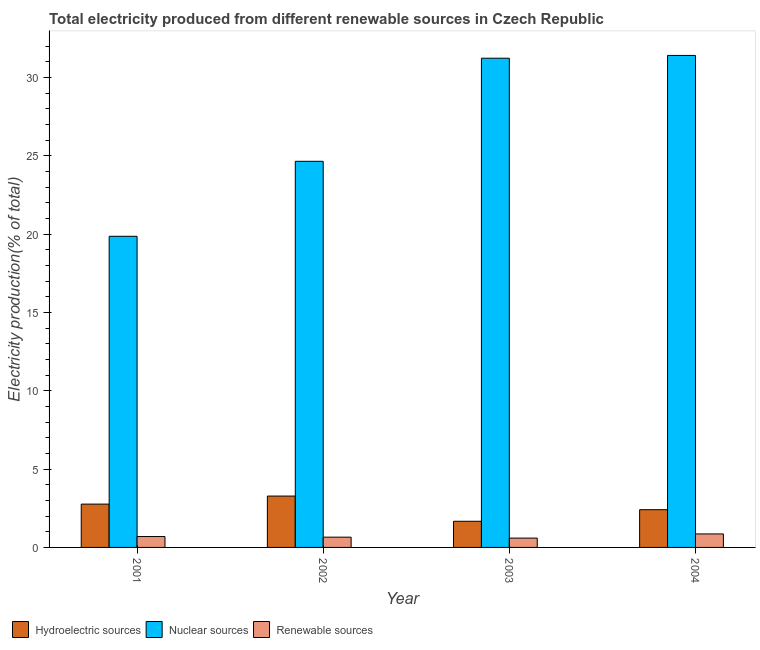How many different coloured bars are there?
Your answer should be very brief. 3. How many bars are there on the 4th tick from the left?
Offer a very short reply. 3. In how many cases, is the number of bars for a given year not equal to the number of legend labels?
Give a very brief answer. 0. What is the percentage of electricity produced by nuclear sources in 2004?
Provide a succinct answer. 31.42. Across all years, what is the maximum percentage of electricity produced by renewable sources?
Provide a short and direct response. 0.86. Across all years, what is the minimum percentage of electricity produced by hydroelectric sources?
Provide a short and direct response. 1.67. In which year was the percentage of electricity produced by hydroelectric sources maximum?
Ensure brevity in your answer.  2002. In which year was the percentage of electricity produced by hydroelectric sources minimum?
Your response must be concise. 2003. What is the total percentage of electricity produced by hydroelectric sources in the graph?
Give a very brief answer. 10.13. What is the difference between the percentage of electricity produced by renewable sources in 2002 and that in 2004?
Your answer should be compact. -0.21. What is the difference between the percentage of electricity produced by hydroelectric sources in 2003 and the percentage of electricity produced by nuclear sources in 2001?
Provide a succinct answer. -1.1. What is the average percentage of electricity produced by hydroelectric sources per year?
Your answer should be very brief. 2.53. In the year 2004, what is the difference between the percentage of electricity produced by hydroelectric sources and percentage of electricity produced by renewable sources?
Your response must be concise. 0. What is the ratio of the percentage of electricity produced by hydroelectric sources in 2002 to that in 2004?
Offer a terse response. 1.36. What is the difference between the highest and the second highest percentage of electricity produced by hydroelectric sources?
Make the answer very short. 0.51. What is the difference between the highest and the lowest percentage of electricity produced by nuclear sources?
Your answer should be very brief. 11.55. In how many years, is the percentage of electricity produced by nuclear sources greater than the average percentage of electricity produced by nuclear sources taken over all years?
Your response must be concise. 2. What does the 1st bar from the left in 2001 represents?
Ensure brevity in your answer.  Hydroelectric sources. What does the 1st bar from the right in 2004 represents?
Make the answer very short. Renewable sources. Is it the case that in every year, the sum of the percentage of electricity produced by hydroelectric sources and percentage of electricity produced by nuclear sources is greater than the percentage of electricity produced by renewable sources?
Ensure brevity in your answer.  Yes. How many bars are there?
Make the answer very short. 12. How many years are there in the graph?
Your answer should be very brief. 4. What is the difference between two consecutive major ticks on the Y-axis?
Offer a terse response. 5. Does the graph contain any zero values?
Your answer should be compact. No. Does the graph contain grids?
Make the answer very short. No. What is the title of the graph?
Offer a terse response. Total electricity produced from different renewable sources in Czech Republic. Does "Refusal of sex" appear as one of the legend labels in the graph?
Provide a short and direct response. No. What is the label or title of the Y-axis?
Ensure brevity in your answer.  Electricity production(% of total). What is the Electricity production(% of total) of Hydroelectric sources in 2001?
Your answer should be compact. 2.77. What is the Electricity production(% of total) in Nuclear sources in 2001?
Your answer should be compact. 19.87. What is the Electricity production(% of total) of Renewable sources in 2001?
Your answer should be very brief. 0.7. What is the Electricity production(% of total) in Hydroelectric sources in 2002?
Ensure brevity in your answer.  3.28. What is the Electricity production(% of total) in Nuclear sources in 2002?
Offer a very short reply. 24.66. What is the Electricity production(% of total) of Renewable sources in 2002?
Offer a very short reply. 0.66. What is the Electricity production(% of total) in Hydroelectric sources in 2003?
Your answer should be compact. 1.67. What is the Electricity production(% of total) in Nuclear sources in 2003?
Provide a succinct answer. 31.24. What is the Electricity production(% of total) of Renewable sources in 2003?
Provide a succinct answer. 0.6. What is the Electricity production(% of total) in Hydroelectric sources in 2004?
Keep it short and to the point. 2.41. What is the Electricity production(% of total) of Nuclear sources in 2004?
Your response must be concise. 31.42. What is the Electricity production(% of total) in Renewable sources in 2004?
Offer a terse response. 0.86. Across all years, what is the maximum Electricity production(% of total) in Hydroelectric sources?
Offer a terse response. 3.28. Across all years, what is the maximum Electricity production(% of total) in Nuclear sources?
Ensure brevity in your answer.  31.42. Across all years, what is the maximum Electricity production(% of total) in Renewable sources?
Your answer should be very brief. 0.86. Across all years, what is the minimum Electricity production(% of total) of Hydroelectric sources?
Keep it short and to the point. 1.67. Across all years, what is the minimum Electricity production(% of total) of Nuclear sources?
Your answer should be compact. 19.87. Across all years, what is the minimum Electricity production(% of total) in Renewable sources?
Keep it short and to the point. 0.6. What is the total Electricity production(% of total) of Hydroelectric sources in the graph?
Make the answer very short. 10.13. What is the total Electricity production(% of total) in Nuclear sources in the graph?
Your answer should be compact. 107.18. What is the total Electricity production(% of total) in Renewable sources in the graph?
Your answer should be very brief. 2.81. What is the difference between the Electricity production(% of total) in Hydroelectric sources in 2001 and that in 2002?
Your response must be concise. -0.51. What is the difference between the Electricity production(% of total) of Nuclear sources in 2001 and that in 2002?
Ensure brevity in your answer.  -4.79. What is the difference between the Electricity production(% of total) of Renewable sources in 2001 and that in 2002?
Your answer should be very brief. 0.04. What is the difference between the Electricity production(% of total) in Hydroelectric sources in 2001 and that in 2003?
Your answer should be very brief. 1.1. What is the difference between the Electricity production(% of total) in Nuclear sources in 2001 and that in 2003?
Ensure brevity in your answer.  -11.37. What is the difference between the Electricity production(% of total) in Renewable sources in 2001 and that in 2003?
Your response must be concise. 0.1. What is the difference between the Electricity production(% of total) in Hydroelectric sources in 2001 and that in 2004?
Offer a very short reply. 0.36. What is the difference between the Electricity production(% of total) in Nuclear sources in 2001 and that in 2004?
Offer a terse response. -11.55. What is the difference between the Electricity production(% of total) of Renewable sources in 2001 and that in 2004?
Your answer should be compact. -0.17. What is the difference between the Electricity production(% of total) of Hydroelectric sources in 2002 and that in 2003?
Your answer should be compact. 1.61. What is the difference between the Electricity production(% of total) of Nuclear sources in 2002 and that in 2003?
Make the answer very short. -6.58. What is the difference between the Electricity production(% of total) of Hydroelectric sources in 2002 and that in 2004?
Give a very brief answer. 0.87. What is the difference between the Electricity production(% of total) of Nuclear sources in 2002 and that in 2004?
Provide a succinct answer. -6.76. What is the difference between the Electricity production(% of total) of Renewable sources in 2002 and that in 2004?
Your response must be concise. -0.21. What is the difference between the Electricity production(% of total) of Hydroelectric sources in 2003 and that in 2004?
Give a very brief answer. -0.74. What is the difference between the Electricity production(% of total) in Nuclear sources in 2003 and that in 2004?
Keep it short and to the point. -0.18. What is the difference between the Electricity production(% of total) in Renewable sources in 2003 and that in 2004?
Your answer should be very brief. -0.27. What is the difference between the Electricity production(% of total) of Hydroelectric sources in 2001 and the Electricity production(% of total) of Nuclear sources in 2002?
Make the answer very short. -21.89. What is the difference between the Electricity production(% of total) of Hydroelectric sources in 2001 and the Electricity production(% of total) of Renewable sources in 2002?
Your answer should be compact. 2.11. What is the difference between the Electricity production(% of total) of Nuclear sources in 2001 and the Electricity production(% of total) of Renewable sources in 2002?
Your response must be concise. 19.21. What is the difference between the Electricity production(% of total) of Hydroelectric sources in 2001 and the Electricity production(% of total) of Nuclear sources in 2003?
Keep it short and to the point. -28.47. What is the difference between the Electricity production(% of total) of Hydroelectric sources in 2001 and the Electricity production(% of total) of Renewable sources in 2003?
Your answer should be compact. 2.17. What is the difference between the Electricity production(% of total) of Nuclear sources in 2001 and the Electricity production(% of total) of Renewable sources in 2003?
Give a very brief answer. 19.27. What is the difference between the Electricity production(% of total) in Hydroelectric sources in 2001 and the Electricity production(% of total) in Nuclear sources in 2004?
Provide a short and direct response. -28.65. What is the difference between the Electricity production(% of total) in Hydroelectric sources in 2001 and the Electricity production(% of total) in Renewable sources in 2004?
Your answer should be compact. 1.91. What is the difference between the Electricity production(% of total) of Nuclear sources in 2001 and the Electricity production(% of total) of Renewable sources in 2004?
Your answer should be compact. 19.01. What is the difference between the Electricity production(% of total) in Hydroelectric sources in 2002 and the Electricity production(% of total) in Nuclear sources in 2003?
Keep it short and to the point. -27.96. What is the difference between the Electricity production(% of total) of Hydroelectric sources in 2002 and the Electricity production(% of total) of Renewable sources in 2003?
Your response must be concise. 2.68. What is the difference between the Electricity production(% of total) of Nuclear sources in 2002 and the Electricity production(% of total) of Renewable sources in 2003?
Provide a succinct answer. 24.06. What is the difference between the Electricity production(% of total) in Hydroelectric sources in 2002 and the Electricity production(% of total) in Nuclear sources in 2004?
Give a very brief answer. -28.14. What is the difference between the Electricity production(% of total) of Hydroelectric sources in 2002 and the Electricity production(% of total) of Renewable sources in 2004?
Offer a terse response. 2.42. What is the difference between the Electricity production(% of total) of Nuclear sources in 2002 and the Electricity production(% of total) of Renewable sources in 2004?
Provide a short and direct response. 23.8. What is the difference between the Electricity production(% of total) in Hydroelectric sources in 2003 and the Electricity production(% of total) in Nuclear sources in 2004?
Provide a short and direct response. -29.75. What is the difference between the Electricity production(% of total) in Hydroelectric sources in 2003 and the Electricity production(% of total) in Renewable sources in 2004?
Your answer should be very brief. 0.81. What is the difference between the Electricity production(% of total) of Nuclear sources in 2003 and the Electricity production(% of total) of Renewable sources in 2004?
Keep it short and to the point. 30.38. What is the average Electricity production(% of total) of Hydroelectric sources per year?
Make the answer very short. 2.53. What is the average Electricity production(% of total) of Nuclear sources per year?
Provide a short and direct response. 26.8. What is the average Electricity production(% of total) of Renewable sources per year?
Your answer should be compact. 0.7. In the year 2001, what is the difference between the Electricity production(% of total) of Hydroelectric sources and Electricity production(% of total) of Nuclear sources?
Provide a short and direct response. -17.1. In the year 2001, what is the difference between the Electricity production(% of total) in Hydroelectric sources and Electricity production(% of total) in Renewable sources?
Keep it short and to the point. 2.07. In the year 2001, what is the difference between the Electricity production(% of total) of Nuclear sources and Electricity production(% of total) of Renewable sources?
Ensure brevity in your answer.  19.17. In the year 2002, what is the difference between the Electricity production(% of total) in Hydroelectric sources and Electricity production(% of total) in Nuclear sources?
Provide a short and direct response. -21.38. In the year 2002, what is the difference between the Electricity production(% of total) in Hydroelectric sources and Electricity production(% of total) in Renewable sources?
Offer a very short reply. 2.62. In the year 2002, what is the difference between the Electricity production(% of total) in Nuclear sources and Electricity production(% of total) in Renewable sources?
Offer a terse response. 24. In the year 2003, what is the difference between the Electricity production(% of total) of Hydroelectric sources and Electricity production(% of total) of Nuclear sources?
Ensure brevity in your answer.  -29.57. In the year 2003, what is the difference between the Electricity production(% of total) of Hydroelectric sources and Electricity production(% of total) of Renewable sources?
Provide a succinct answer. 1.07. In the year 2003, what is the difference between the Electricity production(% of total) in Nuclear sources and Electricity production(% of total) in Renewable sources?
Ensure brevity in your answer.  30.64. In the year 2004, what is the difference between the Electricity production(% of total) of Hydroelectric sources and Electricity production(% of total) of Nuclear sources?
Give a very brief answer. -29.01. In the year 2004, what is the difference between the Electricity production(% of total) in Hydroelectric sources and Electricity production(% of total) in Renewable sources?
Your answer should be compact. 1.55. In the year 2004, what is the difference between the Electricity production(% of total) of Nuclear sources and Electricity production(% of total) of Renewable sources?
Provide a succinct answer. 30.56. What is the ratio of the Electricity production(% of total) in Hydroelectric sources in 2001 to that in 2002?
Ensure brevity in your answer.  0.84. What is the ratio of the Electricity production(% of total) in Nuclear sources in 2001 to that in 2002?
Make the answer very short. 0.81. What is the ratio of the Electricity production(% of total) in Renewable sources in 2001 to that in 2002?
Your answer should be very brief. 1.06. What is the ratio of the Electricity production(% of total) in Hydroelectric sources in 2001 to that in 2003?
Offer a terse response. 1.66. What is the ratio of the Electricity production(% of total) of Nuclear sources in 2001 to that in 2003?
Offer a terse response. 0.64. What is the ratio of the Electricity production(% of total) in Renewable sources in 2001 to that in 2003?
Make the answer very short. 1.17. What is the ratio of the Electricity production(% of total) in Hydroelectric sources in 2001 to that in 2004?
Offer a terse response. 1.15. What is the ratio of the Electricity production(% of total) in Nuclear sources in 2001 to that in 2004?
Your response must be concise. 0.63. What is the ratio of the Electricity production(% of total) of Renewable sources in 2001 to that in 2004?
Provide a short and direct response. 0.81. What is the ratio of the Electricity production(% of total) in Hydroelectric sources in 2002 to that in 2003?
Your answer should be compact. 1.96. What is the ratio of the Electricity production(% of total) of Nuclear sources in 2002 to that in 2003?
Keep it short and to the point. 0.79. What is the ratio of the Electricity production(% of total) in Renewable sources in 2002 to that in 2003?
Offer a very short reply. 1.1. What is the ratio of the Electricity production(% of total) in Hydroelectric sources in 2002 to that in 2004?
Keep it short and to the point. 1.36. What is the ratio of the Electricity production(% of total) in Nuclear sources in 2002 to that in 2004?
Provide a short and direct response. 0.78. What is the ratio of the Electricity production(% of total) of Renewable sources in 2002 to that in 2004?
Make the answer very short. 0.76. What is the ratio of the Electricity production(% of total) in Hydroelectric sources in 2003 to that in 2004?
Offer a terse response. 0.69. What is the ratio of the Electricity production(% of total) in Renewable sources in 2003 to that in 2004?
Ensure brevity in your answer.  0.69. What is the difference between the highest and the second highest Electricity production(% of total) of Hydroelectric sources?
Your response must be concise. 0.51. What is the difference between the highest and the second highest Electricity production(% of total) in Nuclear sources?
Give a very brief answer. 0.18. What is the difference between the highest and the second highest Electricity production(% of total) in Renewable sources?
Offer a very short reply. 0.17. What is the difference between the highest and the lowest Electricity production(% of total) of Hydroelectric sources?
Your answer should be compact. 1.61. What is the difference between the highest and the lowest Electricity production(% of total) in Nuclear sources?
Your response must be concise. 11.55. What is the difference between the highest and the lowest Electricity production(% of total) in Renewable sources?
Offer a terse response. 0.27. 